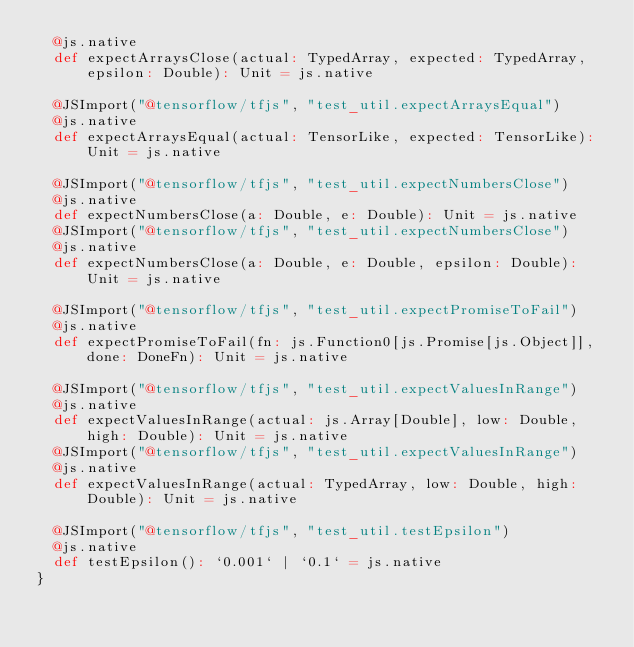<code> <loc_0><loc_0><loc_500><loc_500><_Scala_>  @js.native
  def expectArraysClose(actual: TypedArray, expected: TypedArray, epsilon: Double): Unit = js.native
  
  @JSImport("@tensorflow/tfjs", "test_util.expectArraysEqual")
  @js.native
  def expectArraysEqual(actual: TensorLike, expected: TensorLike): Unit = js.native
  
  @JSImport("@tensorflow/tfjs", "test_util.expectNumbersClose")
  @js.native
  def expectNumbersClose(a: Double, e: Double): Unit = js.native
  @JSImport("@tensorflow/tfjs", "test_util.expectNumbersClose")
  @js.native
  def expectNumbersClose(a: Double, e: Double, epsilon: Double): Unit = js.native
  
  @JSImport("@tensorflow/tfjs", "test_util.expectPromiseToFail")
  @js.native
  def expectPromiseToFail(fn: js.Function0[js.Promise[js.Object]], done: DoneFn): Unit = js.native
  
  @JSImport("@tensorflow/tfjs", "test_util.expectValuesInRange")
  @js.native
  def expectValuesInRange(actual: js.Array[Double], low: Double, high: Double): Unit = js.native
  @JSImport("@tensorflow/tfjs", "test_util.expectValuesInRange")
  @js.native
  def expectValuesInRange(actual: TypedArray, low: Double, high: Double): Unit = js.native
  
  @JSImport("@tensorflow/tfjs", "test_util.testEpsilon")
  @js.native
  def testEpsilon(): `0.001` | `0.1` = js.native
}
</code> 